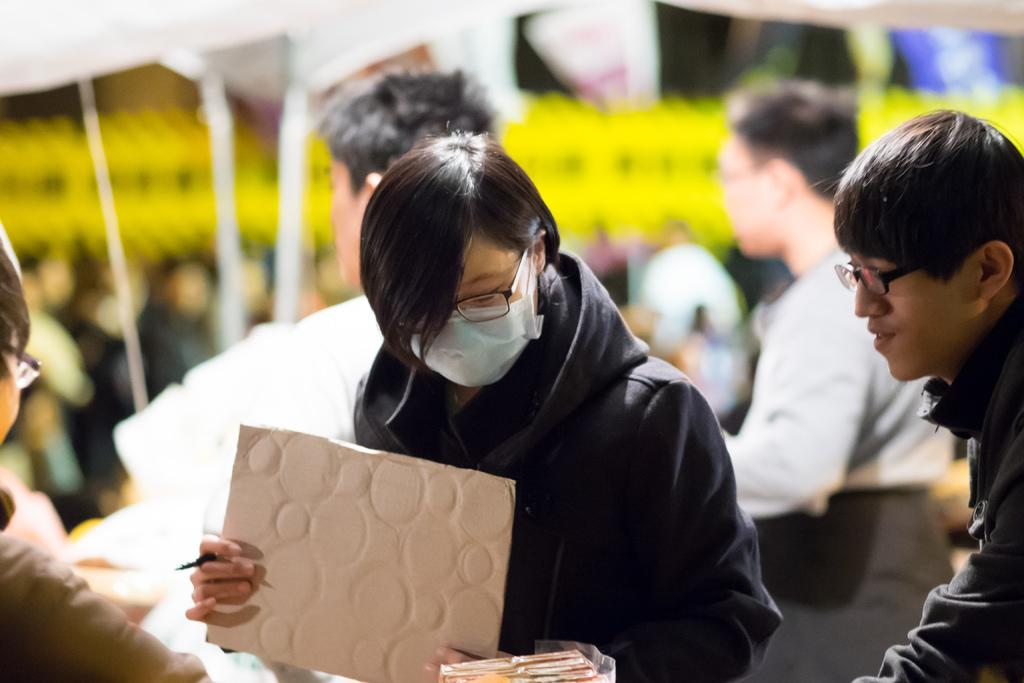What are the people in the image doing? The people in the image are standing and holding a board and a pen. What might the people be using the pen for? The people might be using the pen to write or draw on the board. Can you describe the background of the image? The background of the image is blurred. What type of cloud can be seen in the image? There is no cloud visible in the image; the background is blurred. How does the needle help the people in the image? There is no needle present in the image, so it cannot help the people in any way. 